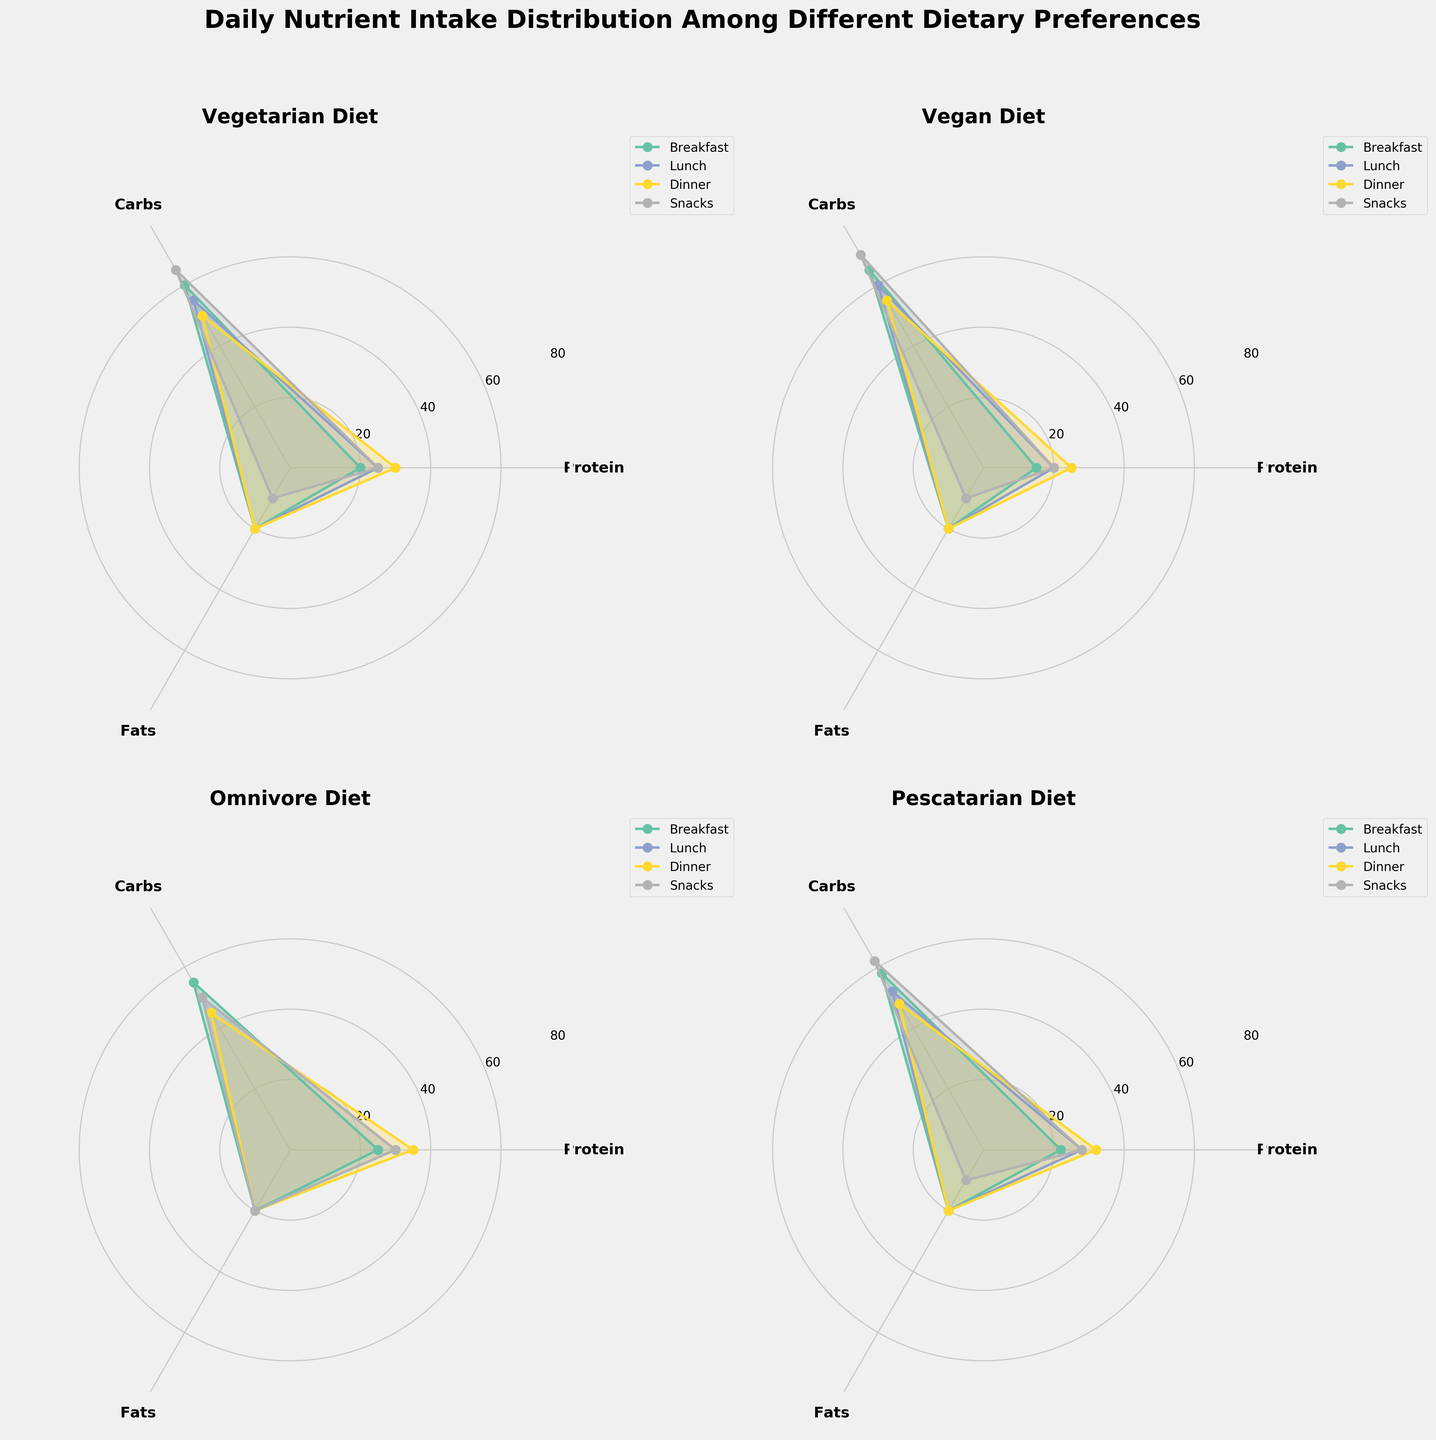Which diet has the highest protein intake during dinner? To find the answer, look at the dinner segment in each subplot. Observe the protein values. The Omnivore diet has higher values compared to the other diets.
Answer: Omnivore What is the average carb intake for the Vegan diet throughout the day? The Vegan diet's carb intakes are 65, 60, 55, and 70 for Breakfast, Lunch, Dinner, and Snacks respectively. Sum them up (65 + 60 + 55 + 70) = 250 and divide by 4, the number of meals. 250 / 4 gives 62.5.
Answer: 62.5 Which diet category has the most equal distribution of fats across all meals? Compare the fats segment in each diet's subplot. The Vegetarian and Omnivore diets have static values of 20 for Breakfast, Lunch, and Dinner, and 10 for Snacks. This distribution is equal and stands out among other diets.
Answer: Vegetarian, Omnivore Compare the protein intake during lunch between Vegetarian and Pescatarian diets. Which one is higher? Look at the Lunch segments for both Vegetarian (25) and Pescatarian (28) diets. Compare them. The Pescatarian diet has a higher protein intake than the Vegetarian diet at lunch.
Answer: Pescatarian What is the total fat intake for the Omnivore diet across all meals? Sum the fats from all meal segments for the Omnivore diet. Fats are 20 each for Breakfast, Lunch, and Dinner, and 20 for Snacks. So, the total is 20 + 20 + 20 + 20 = 80.
Answer: 80 Which meal in the Pescatarian diet contains the highest percentage of carbs? Look at the carb values for each meal in the Pescatarian diet. Breakfast has 58, Lunch has 52, Dinner has 48, and Snacks have 62. Snacks have the highest carb percentage at 62.
Answer: Snacks During Snacks, which diet has the lowest protein intake? In the Snacks segment of each diet, compare the protein values. Vegan and Pescatarian diets each have 20 grams, Omnivore has 30, and Vegetarian 25. Vegan and Pescatarian diets tie with the lowest protein intake at 20.
Answer: Vegan, Pescatarian Examine the shape of the Polar Chart for Vegans and describe the symmetry. Looking at the subplots, Vegans’ chart for each macronutrient shows higher variability in carbs and more stable values in protein and fats.
Answer: Higher in carbs, stable protein and fats In which diet does each meal segment have an identical fat intake of 20, except for snacks? Compare the meals segment for each diet. The Vegetarian and Omnivore diets have identical fat intake (20) for all meals except snacks, where fats drop to 10.
Answer: Vegetarian, Omnivore 